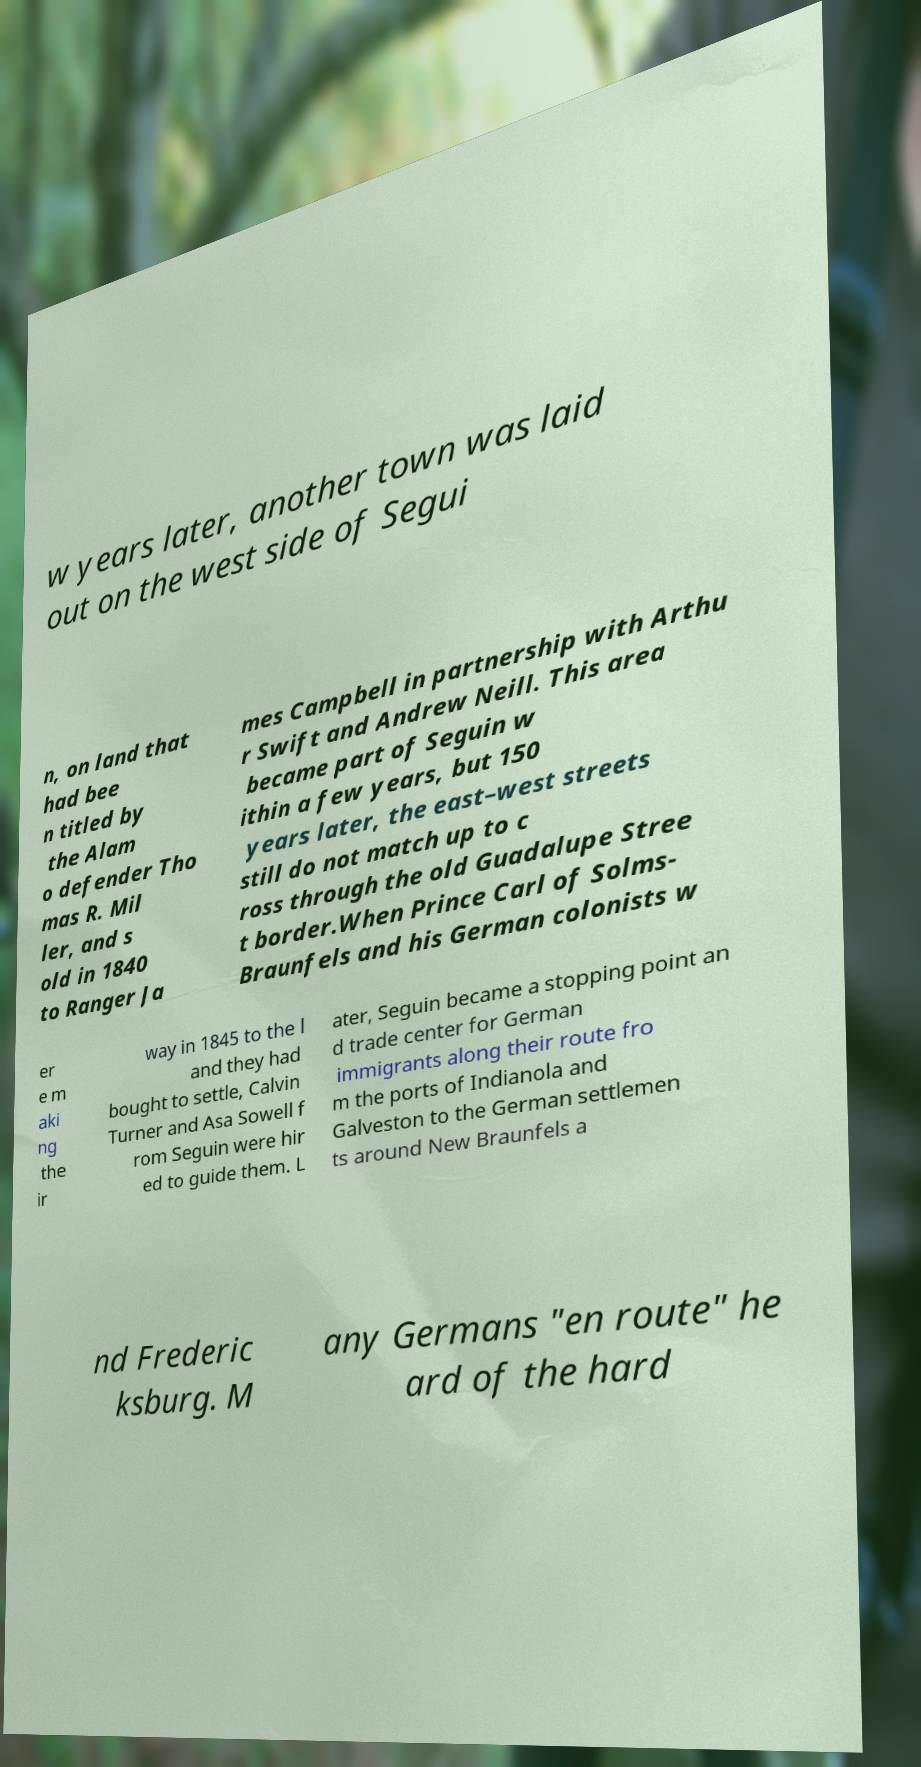There's text embedded in this image that I need extracted. Can you transcribe it verbatim? w years later, another town was laid out on the west side of Segui n, on land that had bee n titled by the Alam o defender Tho mas R. Mil ler, and s old in 1840 to Ranger Ja mes Campbell in partnership with Arthu r Swift and Andrew Neill. This area became part of Seguin w ithin a few years, but 150 years later, the east–west streets still do not match up to c ross through the old Guadalupe Stree t border.When Prince Carl of Solms- Braunfels and his German colonists w er e m aki ng the ir way in 1845 to the l and they had bought to settle, Calvin Turner and Asa Sowell f rom Seguin were hir ed to guide them. L ater, Seguin became a stopping point an d trade center for German immigrants along their route fro m the ports of Indianola and Galveston to the German settlemen ts around New Braunfels a nd Frederic ksburg. M any Germans "en route" he ard of the hard 